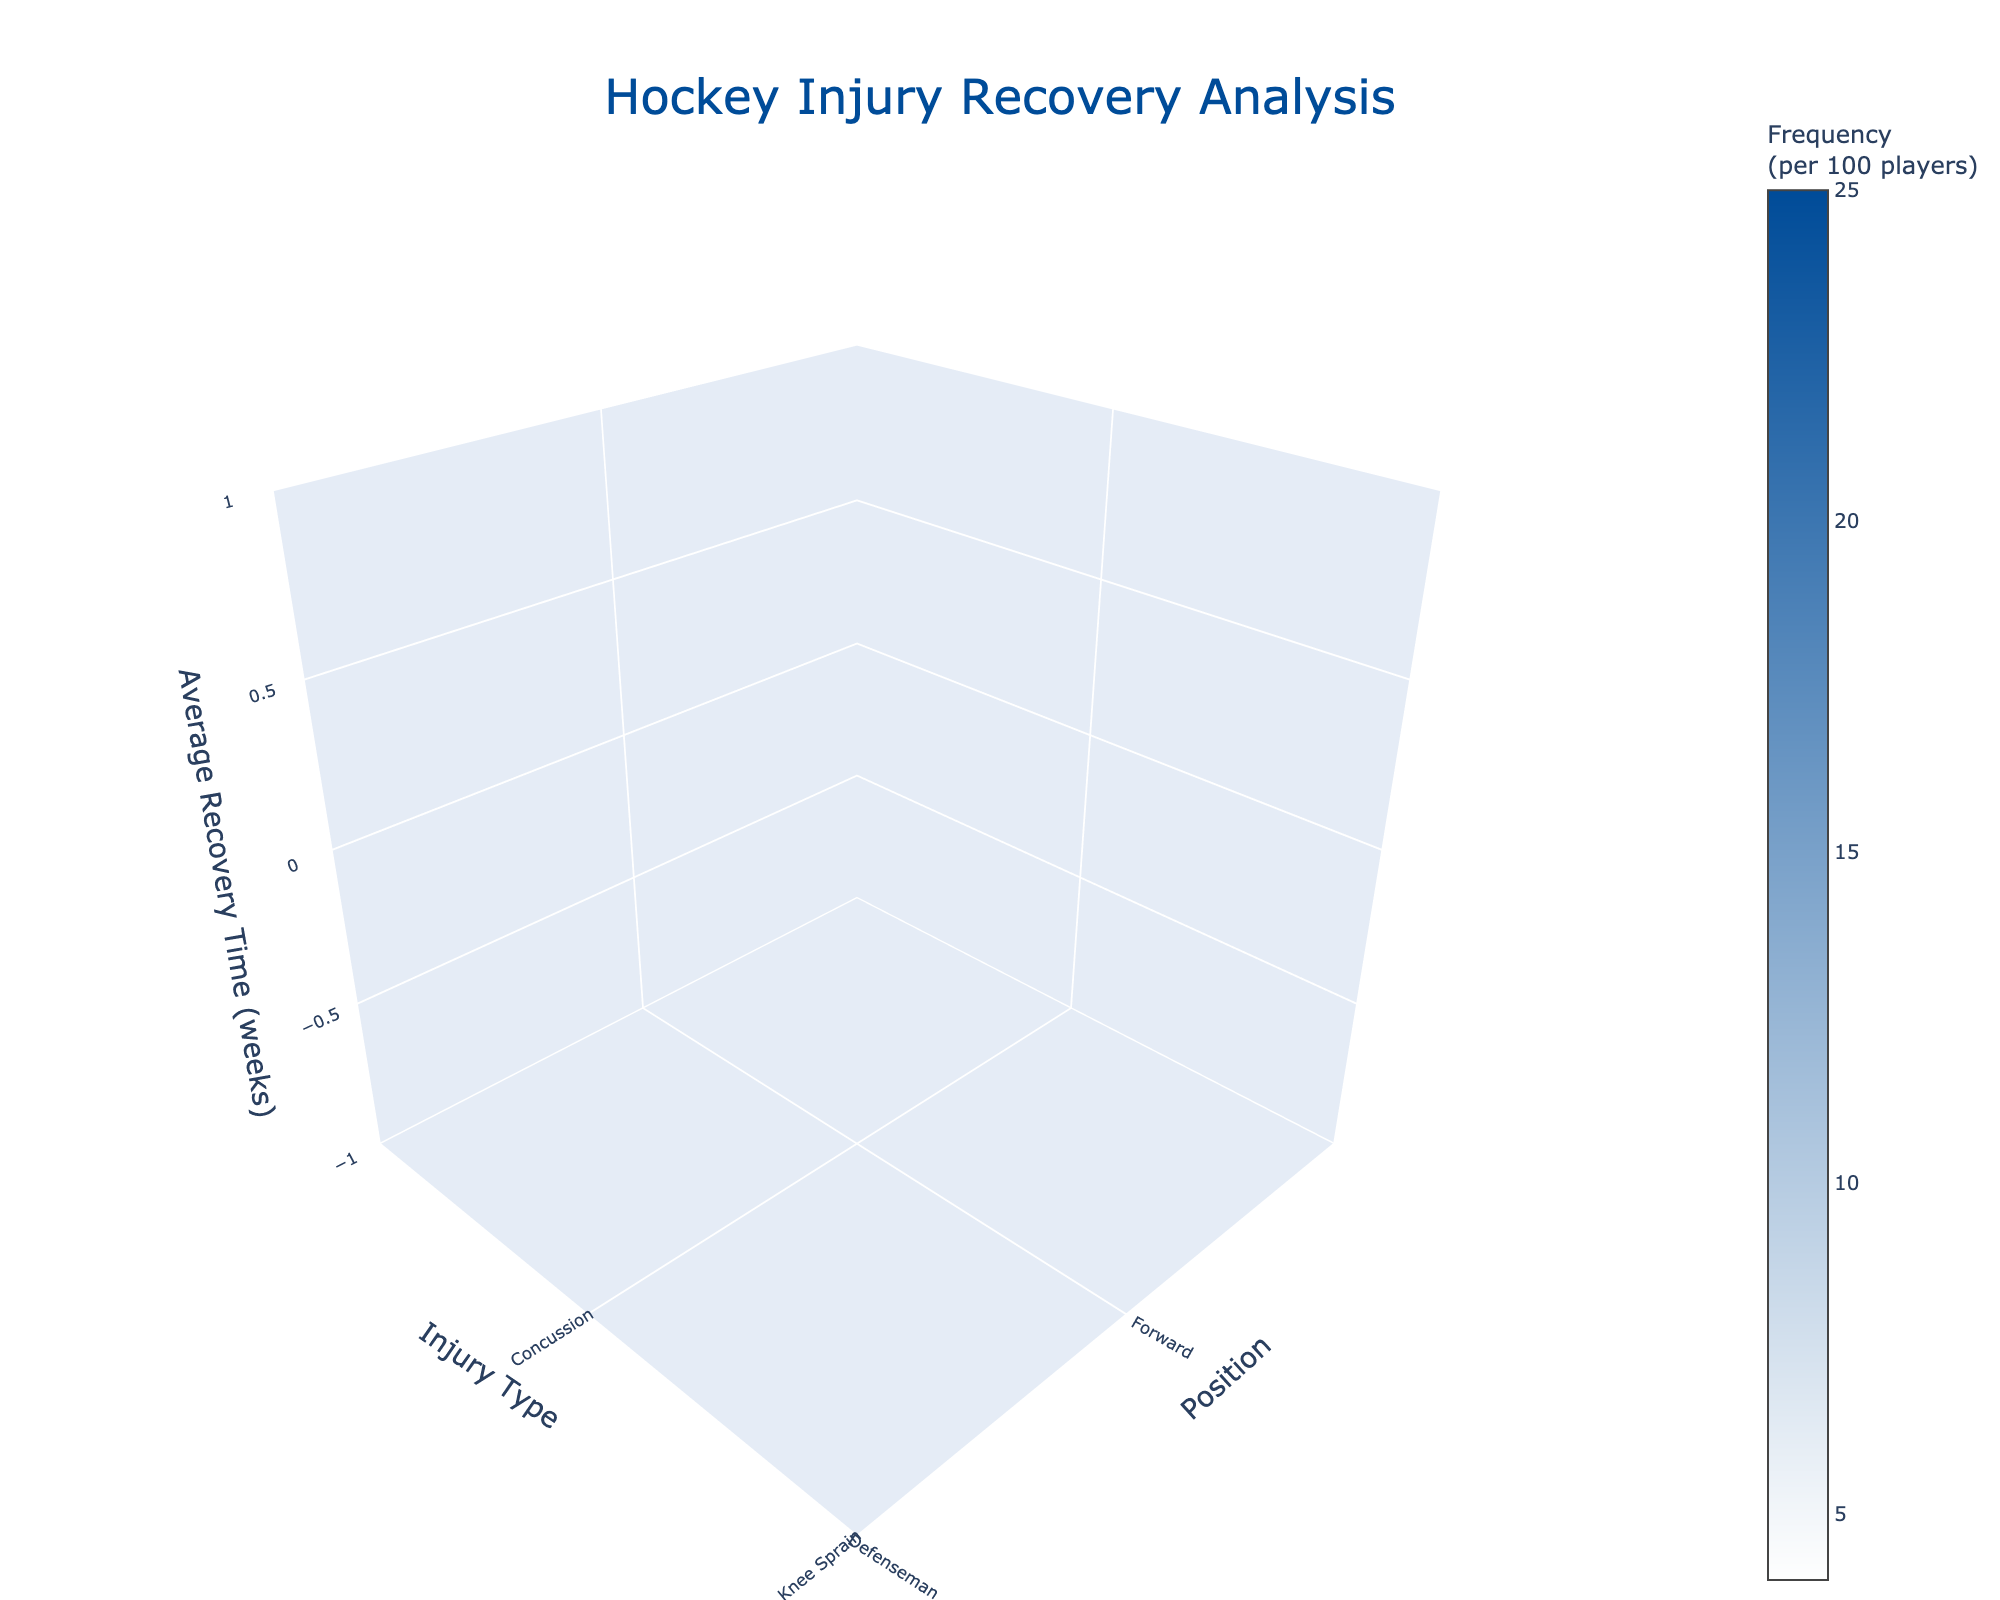What is the title of the 3D volume plot? The title is located at the top of the plot and is designed to summarize the subject matter of the data visualization. In this figure, the title highlights the focus on analyzing hockey injury recovery.
Answer: Hockey Injury Recovery Analysis What are the axis titles in the plot? The axis titles specify what each axis represents in the 3D volume plot. The x-axis represents player positions, the y-axis describes the types of injuries, and the z-axis indicates the average recovery time in weeks.
Answer: Position, Injury Type, Average Recovery Time (weeks) How many injury types are displayed for goalies? To determine this, observe the number of unique injury types along the y-axis for the "Goalie" position. By counting the distinct entries, we can answer this question.
Answer: 5 Which player position has the highest frequency of injuries? To identify this, observe the color gradient along the x-axis for the player positions. The color bar on the plot helps to determine the frequency, and the position with the darkest shade indicates the highest frequency.
Answer: Goalie Which injury type has the longest average recovery time for defensemen? Examine the z-axis values for the "Defenseman" position along with injury types. The injury with the highest z-axis value among defensemen has the longest recovery time.
Answer: MCL Tear Which injury type has the shortest recovery time across all positions? To find the shortest recovery time, look at the z-axis values across all positions and injury types. Identify the minimum value of the z-axis.
Answer: Lower Body Fatigue What's the combined average recovery time for concussions and knee sprains in forwards? First, locate the recovery times for "Concussion" and "Knee Sprain" for forwards, which are 4 and 6 weeks, respectively. Sum these values to find the combined average recovery time.
Answer: 10 weeks Is the frequency of groin pulls higher for goalies or groin strains for forwards? Compare the frequencies of "Groin Pull" for goalies and "Groin Strain" for forwards using the color gradient and the color bar. The darker color represents a higher frequency.
Answer: Groin Pull for goalies Which injury has a higher average recovery time: wrist fractures in defensemen or ankle sprains in forwards? Compare the z-axis values of "Wrist Fracture" for defensemen and "Ankle Sprain" for forwards. Locate these injury types and determine which one has a higher z-axis value.
Answer: Wrist Fracture in defensemen 